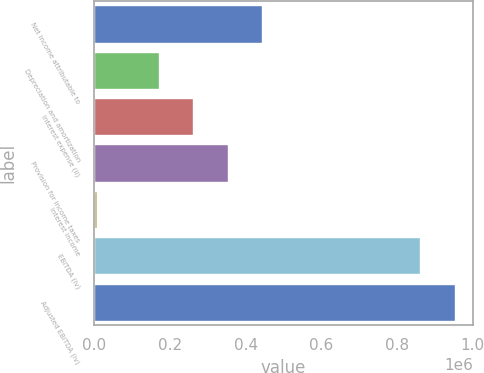Convert chart to OTSL. <chart><loc_0><loc_0><loc_500><loc_500><bar_chart><fcel>Net income attributable to<fcel>Depreciation and amortization<fcel>Interest expense (ii)<fcel>Provision for income taxes<fcel>Interest income<fcel>EBITDA (iv)<fcel>Adjusted EBITDA (iv)<nl><fcel>444143<fcel>170905<fcel>261984<fcel>353063<fcel>7647<fcel>861621<fcel>952700<nl></chart> 